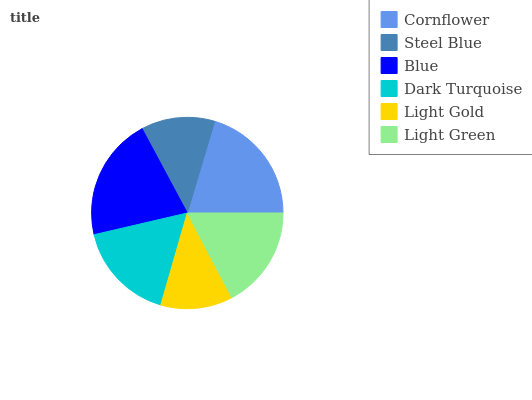Is Light Gold the minimum?
Answer yes or no. Yes. Is Blue the maximum?
Answer yes or no. Yes. Is Steel Blue the minimum?
Answer yes or no. No. Is Steel Blue the maximum?
Answer yes or no. No. Is Cornflower greater than Steel Blue?
Answer yes or no. Yes. Is Steel Blue less than Cornflower?
Answer yes or no. Yes. Is Steel Blue greater than Cornflower?
Answer yes or no. No. Is Cornflower less than Steel Blue?
Answer yes or no. No. Is Light Green the high median?
Answer yes or no. Yes. Is Dark Turquoise the low median?
Answer yes or no. Yes. Is Blue the high median?
Answer yes or no. No. Is Cornflower the low median?
Answer yes or no. No. 